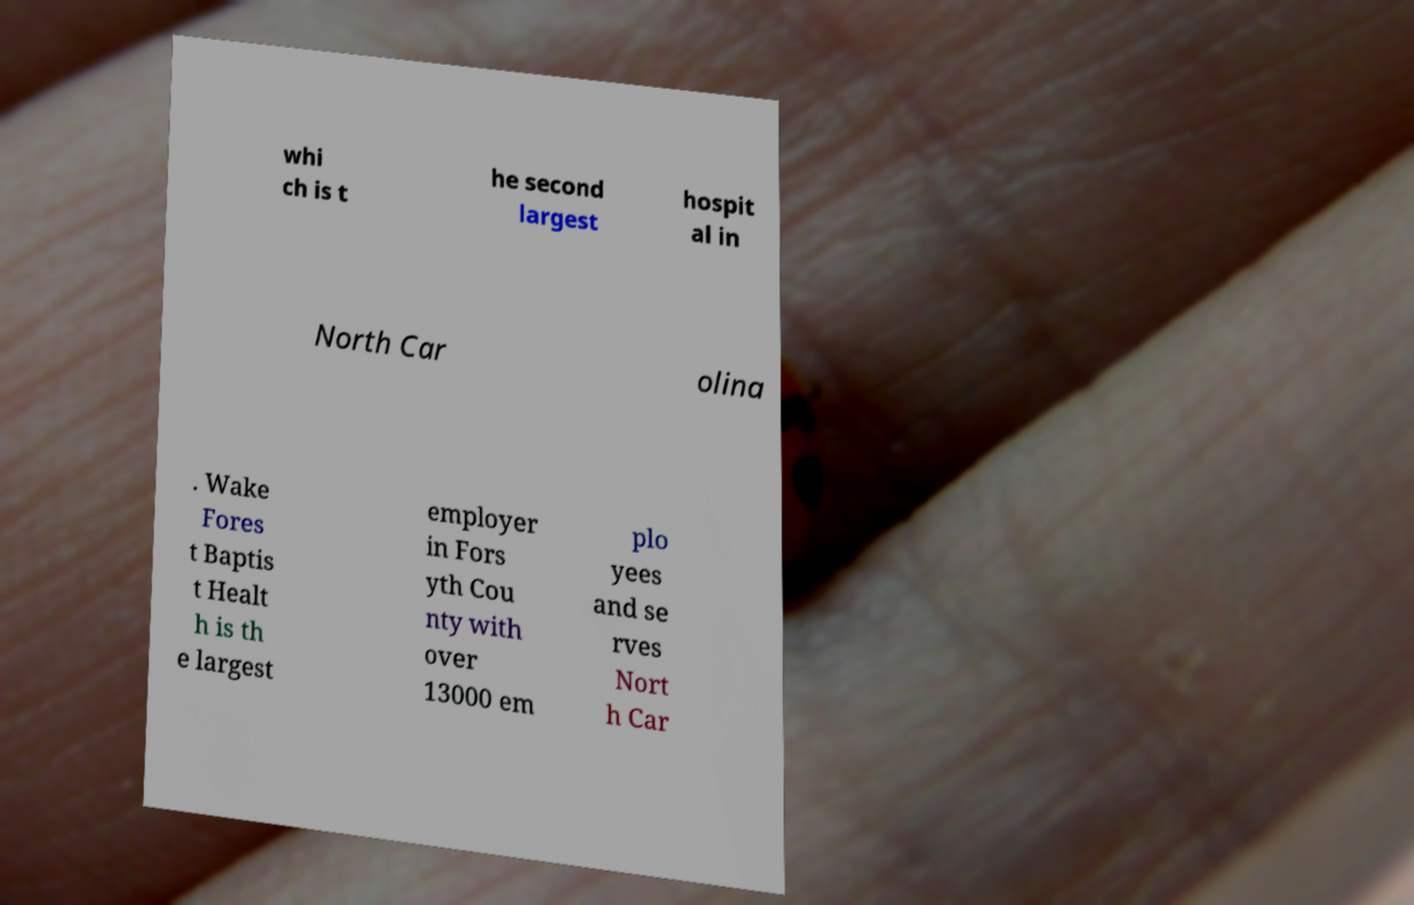Can you accurately transcribe the text from the provided image for me? whi ch is t he second largest hospit al in North Car olina . Wake Fores t Baptis t Healt h is th e largest employer in Fors yth Cou nty with over 13000 em plo yees and se rves Nort h Car 